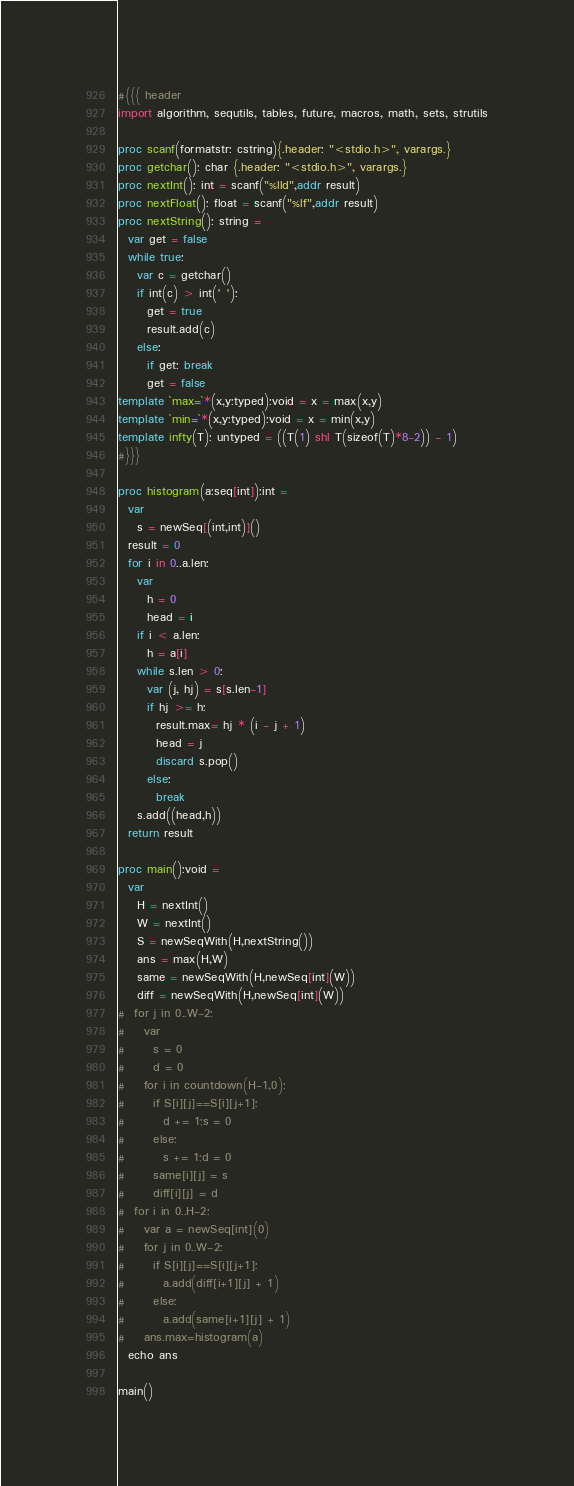<code> <loc_0><loc_0><loc_500><loc_500><_Nim_>#{{{ header
import algorithm, sequtils, tables, future, macros, math, sets, strutils
 
proc scanf(formatstr: cstring){.header: "<stdio.h>", varargs.}
proc getchar(): char {.header: "<stdio.h>", varargs.}
proc nextInt(): int = scanf("%lld",addr result)
proc nextFloat(): float = scanf("%lf",addr result)
proc nextString(): string =
  var get = false
  while true:
    var c = getchar()
    if int(c) > int(' '):
      get = true
      result.add(c)
    else:
      if get: break
      get = false
template `max=`*(x,y:typed):void = x = max(x,y)
template `min=`*(x,y:typed):void = x = min(x,y)
template infty(T): untyped = ((T(1) shl T(sizeof(T)*8-2)) - 1)
#}}}

proc histogram(a:seq[int]):int = 
  var
    s = newSeq[(int,int)]()
  result = 0
  for i in 0..a.len:
    var
      h = 0
      head = i
    if i < a.len:
      h = a[i]
    while s.len > 0:
      var (j, hj) = s[s.len-1]
      if hj >= h:
        result.max= hj * (i - j + 1)
        head = j
        discard s.pop()
      else:
        break
    s.add((head,h))
  return result

proc main():void =
  var
    H = nextInt()
    W = nextInt()
    S = newSeqWith(H,nextString())
    ans = max(H,W)
    same = newSeqWith(H,newSeq[int](W))
    diff = newSeqWith(H,newSeq[int](W))
#  for j in 0..W-2:
#    var
#      s = 0
#      d = 0
#    for i in countdown(H-1,0):
#      if S[i][j]==S[i][j+1]:
#        d += 1;s = 0
#      else:
#        s += 1;d = 0
#      same[i][j] = s
#      diff[i][j] = d
#  for i in 0..H-2:
#    var a = newSeq[int](0)
#    for j in 0..W-2:
#      if S[i][j]==S[i][j+1]:
#        a.add(diff[i+1][j] + 1)
#      else:
#        a.add(same[i+1][j] + 1)
#    ans.max=histogram(a)
  echo ans

main()
</code> 